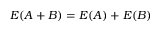Convert formula to latex. <formula><loc_0><loc_0><loc_500><loc_500>E ( A + B ) = E ( A ) + E ( B )</formula> 